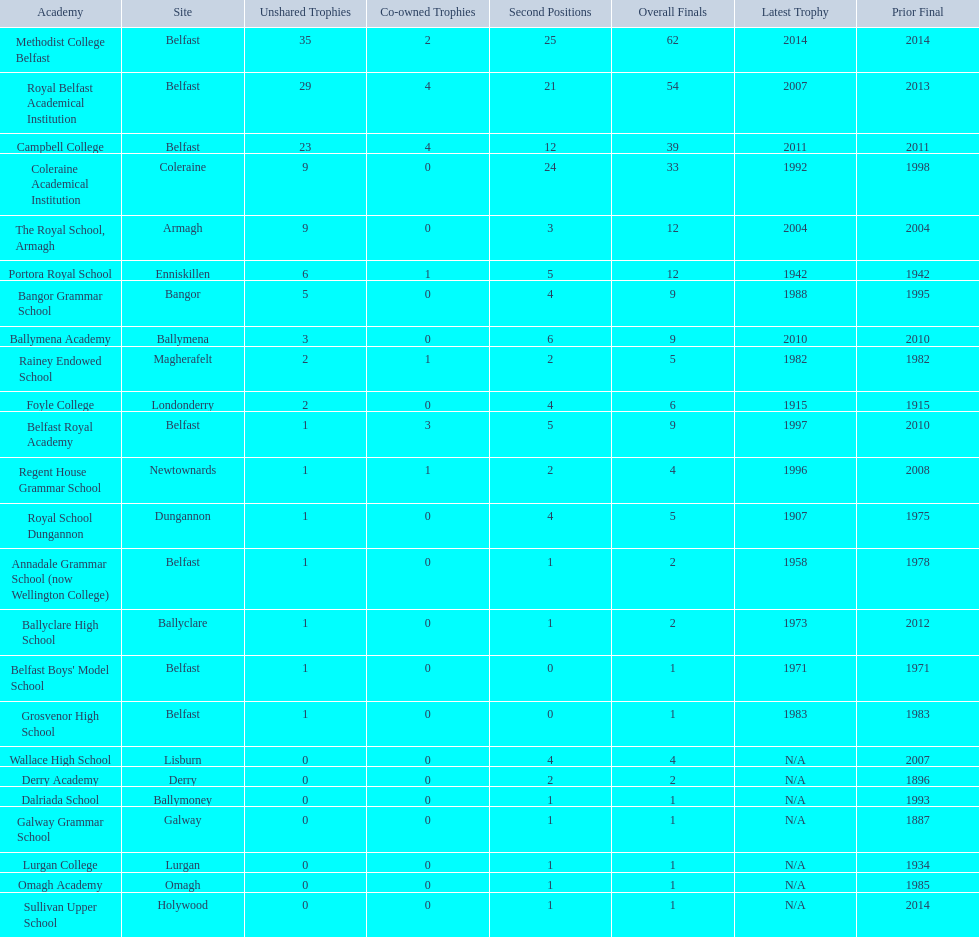Which schools are listed? Methodist College Belfast, Royal Belfast Academical Institution, Campbell College, Coleraine Academical Institution, The Royal School, Armagh, Portora Royal School, Bangor Grammar School, Ballymena Academy, Rainey Endowed School, Foyle College, Belfast Royal Academy, Regent House Grammar School, Royal School Dungannon, Annadale Grammar School (now Wellington College), Ballyclare High School, Belfast Boys' Model School, Grosvenor High School, Wallace High School, Derry Academy, Dalriada School, Galway Grammar School, Lurgan College, Omagh Academy, Sullivan Upper School. When did campbell college win the title last? 2011. When did regent house grammar school win the title last? 1996. Of those two who had the most recent title win? Campbell College. 